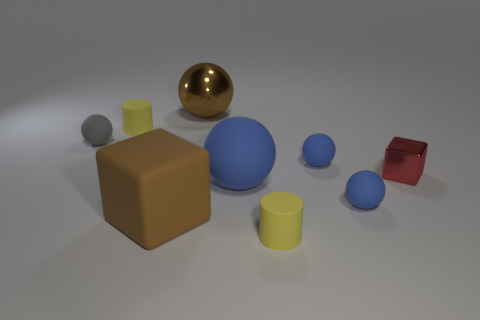Subtract all small blue balls. How many balls are left? 3 Subtract 1 spheres. How many spheres are left? 4 Subtract all red cubes. How many blue spheres are left? 3 Add 1 small matte cylinders. How many objects exist? 10 Subtract all gray balls. How many balls are left? 4 Subtract all cylinders. How many objects are left? 7 Subtract all cyan spheres. Subtract all red blocks. How many spheres are left? 5 Subtract all brown metallic things. Subtract all purple cylinders. How many objects are left? 8 Add 6 large cubes. How many large cubes are left? 7 Add 6 big metallic balls. How many big metallic balls exist? 7 